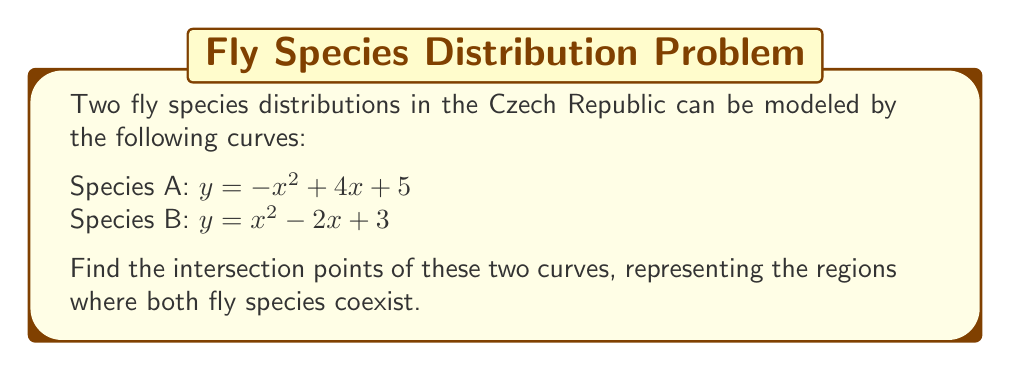Solve this math problem. To find the intersection points, we need to solve the equation where both curves are equal:

1) Set the equations equal to each other:
   $-x^2 + 4x + 5 = x^2 - 2x + 3$

2) Rearrange the equation to standard form:
   $-x^2 + 4x + 5 - (x^2 - 2x + 3) = 0$
   $-2x^2 + 6x + 2 = 0$

3) Divide all terms by -2 to simplify:
   $x^2 - 3x - 1 = 0$

4) This is a quadratic equation in the form $ax^2 + bx + c = 0$, where $a=1$, $b=-3$, and $c=-1$

5) Use the quadratic formula: $x = \frac{-b \pm \sqrt{b^2 - 4ac}}{2a}$

6) Substitute the values:
   $x = \frac{3 \pm \sqrt{(-3)^2 - 4(1)(-1)}}{2(1)}$
   $x = \frac{3 \pm \sqrt{9 + 4}}{2}$
   $x = \frac{3 \pm \sqrt{13}}{2}$

7) Simplify:
   $x_1 = \frac{3 + \sqrt{13}}{2}$ and $x_2 = \frac{3 - \sqrt{13}}{2}$

8) Calculate y-coordinates by substituting x-values into either original equation:
   For $x_1$: $y_1 = -(\frac{3 + \sqrt{13}}{2})^2 + 4(\frac{3 + \sqrt{13}}{2}) + 5$
   For $x_2$: $y_2 = -(\frac{3 - \sqrt{13}}{2})^2 + 4(\frac{3 - \sqrt{13}}{2}) + 5$

9) Simplify to get y-coordinates:
   $y_1 = \frac{23 + 3\sqrt{13}}{2}$ and $y_2 = \frac{23 - 3\sqrt{13}}{2}$
Answer: $(\frac{3 + \sqrt{13}}{2}, \frac{23 + 3\sqrt{13}}{2})$ and $(\frac{3 - \sqrt{13}}{2}, \frac{23 - 3\sqrt{13}}{2})$ 